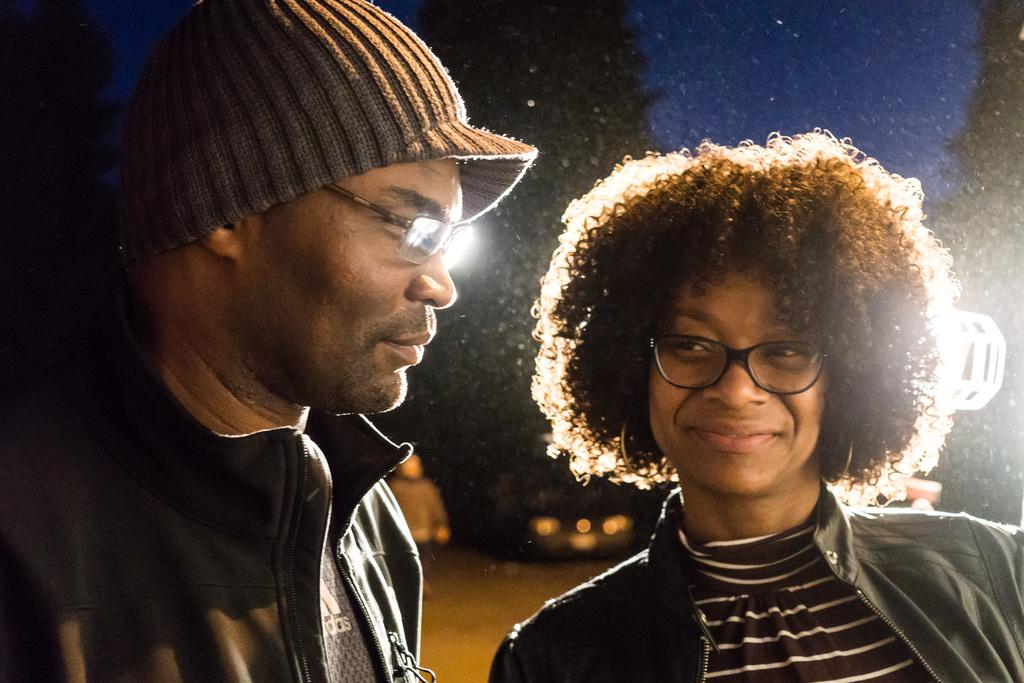How many people are present in the image? There are two people in the image. What can be seen in the background of the image? There is a light and a vehicle in the background of the image. What type of fight is taking place between the two people in the image? There is no fight taking place between the two people in the image; they are simply present together. 